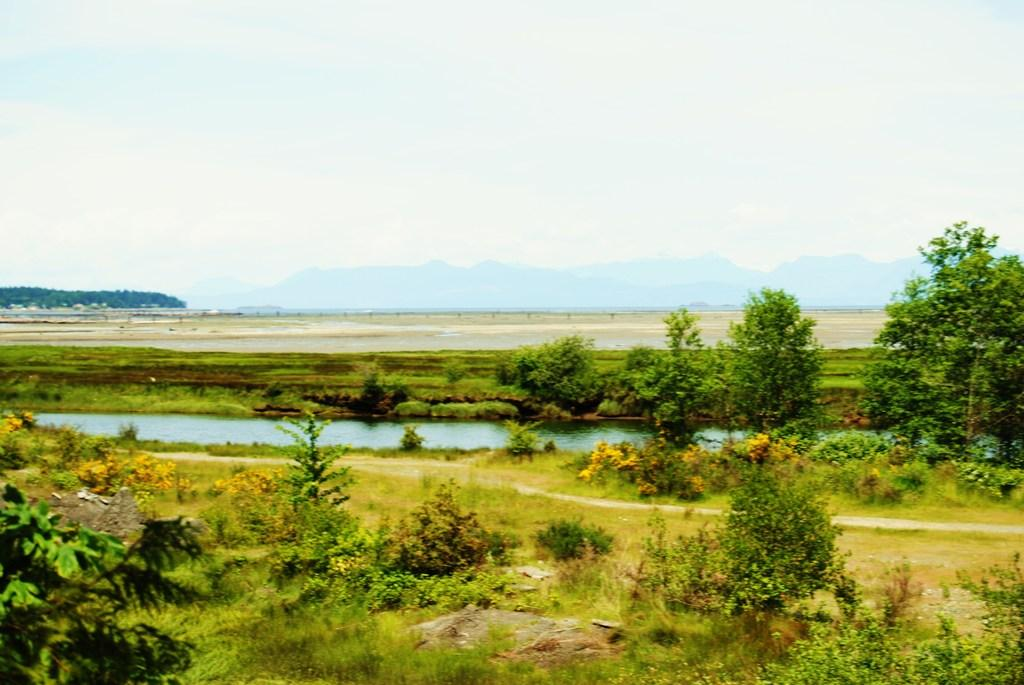What is present in the image that is not solid? There is water visible in the image. What type of vegetation can be seen in the image? There are plants and trees in the image. What type of geographical feature is visible in the image? There are mountains visible in the image. What part of the natural environment is visible in the image? The sky is visible in the image. What type of oven can be seen in the image? There is no oven present in the image. How does the wound on the tree heal in the image? There is no wound on any tree in the image. 